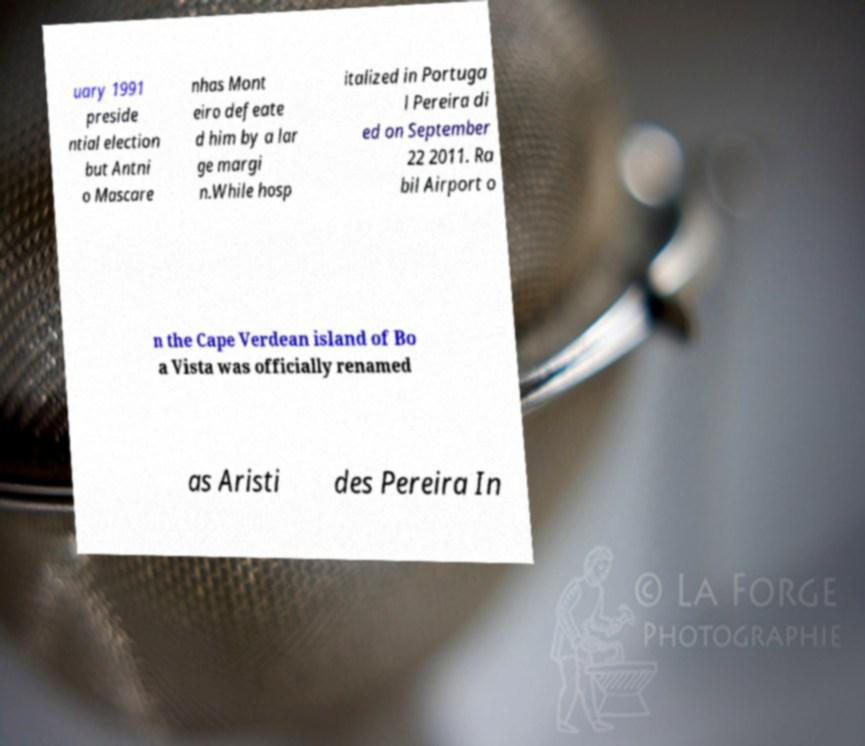Could you extract and type out the text from this image? uary 1991 preside ntial election but Antni o Mascare nhas Mont eiro defeate d him by a lar ge margi n.While hosp italized in Portuga l Pereira di ed on September 22 2011. Ra bil Airport o n the Cape Verdean island of Bo a Vista was officially renamed as Aristi des Pereira In 